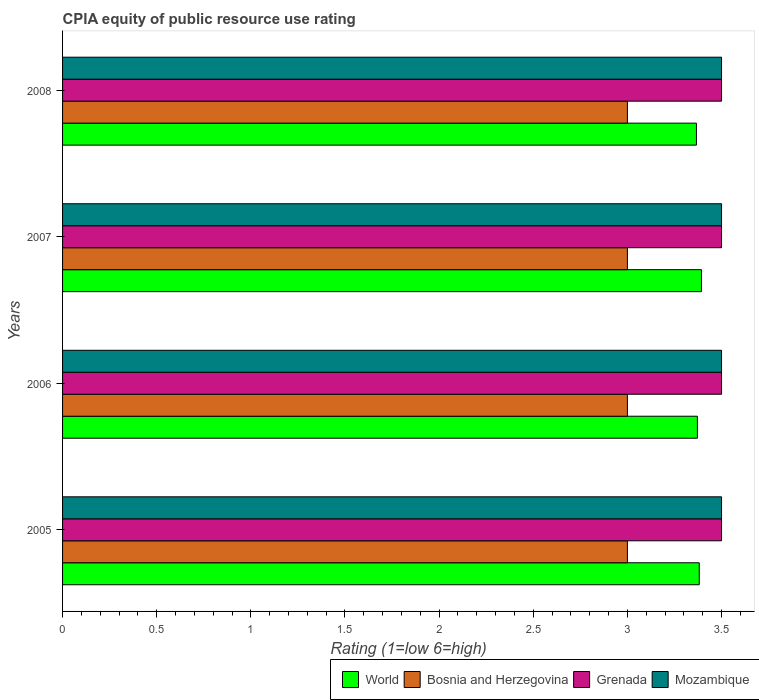How many different coloured bars are there?
Offer a terse response. 4. How many groups of bars are there?
Provide a succinct answer. 4. How many bars are there on the 4th tick from the bottom?
Keep it short and to the point. 4. In how many cases, is the number of bars for a given year not equal to the number of legend labels?
Ensure brevity in your answer.  0. What is the CPIA rating in World in 2005?
Make the answer very short. 3.38. Across all years, what is the maximum CPIA rating in Mozambique?
Your response must be concise. 3.5. In which year was the CPIA rating in Mozambique minimum?
Provide a succinct answer. 2005. What is the difference between the CPIA rating in Grenada in 2006 and the CPIA rating in Bosnia and Herzegovina in 2008?
Keep it short and to the point. 0.5. What is the ratio of the CPIA rating in Grenada in 2005 to that in 2007?
Make the answer very short. 1. Is the CPIA rating in Grenada in 2007 less than that in 2008?
Keep it short and to the point. No. What is the difference between the highest and the lowest CPIA rating in World?
Offer a very short reply. 0.03. Is the sum of the CPIA rating in Bosnia and Herzegovina in 2005 and 2008 greater than the maximum CPIA rating in Mozambique across all years?
Your response must be concise. Yes. Is it the case that in every year, the sum of the CPIA rating in Bosnia and Herzegovina and CPIA rating in World is greater than the sum of CPIA rating in Mozambique and CPIA rating in Grenada?
Give a very brief answer. No. What does the 4th bar from the top in 2008 represents?
Provide a short and direct response. World. What does the 3rd bar from the bottom in 2008 represents?
Provide a short and direct response. Grenada. Is it the case that in every year, the sum of the CPIA rating in Bosnia and Herzegovina and CPIA rating in World is greater than the CPIA rating in Mozambique?
Make the answer very short. Yes. How many bars are there?
Provide a succinct answer. 16. Are all the bars in the graph horizontal?
Keep it short and to the point. Yes. What is the difference between two consecutive major ticks on the X-axis?
Your response must be concise. 0.5. Are the values on the major ticks of X-axis written in scientific E-notation?
Give a very brief answer. No. Does the graph contain any zero values?
Provide a succinct answer. No. Does the graph contain grids?
Give a very brief answer. No. How are the legend labels stacked?
Provide a short and direct response. Horizontal. What is the title of the graph?
Provide a succinct answer. CPIA equity of public resource use rating. Does "Dominican Republic" appear as one of the legend labels in the graph?
Provide a succinct answer. No. What is the label or title of the Y-axis?
Keep it short and to the point. Years. What is the Rating (1=low 6=high) of World in 2005?
Your response must be concise. 3.38. What is the Rating (1=low 6=high) in World in 2006?
Ensure brevity in your answer.  3.37. What is the Rating (1=low 6=high) in Bosnia and Herzegovina in 2006?
Offer a terse response. 3. What is the Rating (1=low 6=high) in World in 2007?
Your answer should be very brief. 3.39. What is the Rating (1=low 6=high) of Bosnia and Herzegovina in 2007?
Offer a terse response. 3. What is the Rating (1=low 6=high) in World in 2008?
Offer a terse response. 3.37. What is the Rating (1=low 6=high) of Grenada in 2008?
Your answer should be very brief. 3.5. Across all years, what is the maximum Rating (1=low 6=high) of World?
Your response must be concise. 3.39. Across all years, what is the maximum Rating (1=low 6=high) in Bosnia and Herzegovina?
Provide a short and direct response. 3. Across all years, what is the minimum Rating (1=low 6=high) of World?
Your answer should be compact. 3.37. What is the total Rating (1=low 6=high) of World in the graph?
Give a very brief answer. 13.51. What is the total Rating (1=low 6=high) of Bosnia and Herzegovina in the graph?
Provide a succinct answer. 12. What is the total Rating (1=low 6=high) in Grenada in the graph?
Offer a very short reply. 14. What is the difference between the Rating (1=low 6=high) in World in 2005 and that in 2006?
Keep it short and to the point. 0.01. What is the difference between the Rating (1=low 6=high) in Bosnia and Herzegovina in 2005 and that in 2006?
Ensure brevity in your answer.  0. What is the difference between the Rating (1=low 6=high) in Grenada in 2005 and that in 2006?
Keep it short and to the point. 0. What is the difference between the Rating (1=low 6=high) in World in 2005 and that in 2007?
Ensure brevity in your answer.  -0.01. What is the difference between the Rating (1=low 6=high) in Bosnia and Herzegovina in 2005 and that in 2007?
Keep it short and to the point. 0. What is the difference between the Rating (1=low 6=high) of Grenada in 2005 and that in 2007?
Make the answer very short. 0. What is the difference between the Rating (1=low 6=high) in World in 2005 and that in 2008?
Offer a terse response. 0.01. What is the difference between the Rating (1=low 6=high) of Bosnia and Herzegovina in 2005 and that in 2008?
Offer a terse response. 0. What is the difference between the Rating (1=low 6=high) in Grenada in 2005 and that in 2008?
Offer a very short reply. 0. What is the difference between the Rating (1=low 6=high) of World in 2006 and that in 2007?
Ensure brevity in your answer.  -0.02. What is the difference between the Rating (1=low 6=high) in World in 2006 and that in 2008?
Make the answer very short. 0.01. What is the difference between the Rating (1=low 6=high) of Grenada in 2006 and that in 2008?
Offer a terse response. 0. What is the difference between the Rating (1=low 6=high) in Mozambique in 2006 and that in 2008?
Your answer should be very brief. 0. What is the difference between the Rating (1=low 6=high) of World in 2007 and that in 2008?
Your answer should be very brief. 0.03. What is the difference between the Rating (1=low 6=high) in Bosnia and Herzegovina in 2007 and that in 2008?
Your answer should be very brief. 0. What is the difference between the Rating (1=low 6=high) of World in 2005 and the Rating (1=low 6=high) of Bosnia and Herzegovina in 2006?
Keep it short and to the point. 0.38. What is the difference between the Rating (1=low 6=high) of World in 2005 and the Rating (1=low 6=high) of Grenada in 2006?
Make the answer very short. -0.12. What is the difference between the Rating (1=low 6=high) of World in 2005 and the Rating (1=low 6=high) of Mozambique in 2006?
Make the answer very short. -0.12. What is the difference between the Rating (1=low 6=high) of Grenada in 2005 and the Rating (1=low 6=high) of Mozambique in 2006?
Give a very brief answer. 0. What is the difference between the Rating (1=low 6=high) in World in 2005 and the Rating (1=low 6=high) in Bosnia and Herzegovina in 2007?
Keep it short and to the point. 0.38. What is the difference between the Rating (1=low 6=high) in World in 2005 and the Rating (1=low 6=high) in Grenada in 2007?
Offer a terse response. -0.12. What is the difference between the Rating (1=low 6=high) of World in 2005 and the Rating (1=low 6=high) of Mozambique in 2007?
Your response must be concise. -0.12. What is the difference between the Rating (1=low 6=high) of Bosnia and Herzegovina in 2005 and the Rating (1=low 6=high) of Grenada in 2007?
Keep it short and to the point. -0.5. What is the difference between the Rating (1=low 6=high) in World in 2005 and the Rating (1=low 6=high) in Bosnia and Herzegovina in 2008?
Give a very brief answer. 0.38. What is the difference between the Rating (1=low 6=high) in World in 2005 and the Rating (1=low 6=high) in Grenada in 2008?
Your answer should be very brief. -0.12. What is the difference between the Rating (1=low 6=high) of World in 2005 and the Rating (1=low 6=high) of Mozambique in 2008?
Your response must be concise. -0.12. What is the difference between the Rating (1=low 6=high) of Bosnia and Herzegovina in 2005 and the Rating (1=low 6=high) of Mozambique in 2008?
Make the answer very short. -0.5. What is the difference between the Rating (1=low 6=high) in World in 2006 and the Rating (1=low 6=high) in Bosnia and Herzegovina in 2007?
Ensure brevity in your answer.  0.37. What is the difference between the Rating (1=low 6=high) in World in 2006 and the Rating (1=low 6=high) in Grenada in 2007?
Your answer should be compact. -0.13. What is the difference between the Rating (1=low 6=high) in World in 2006 and the Rating (1=low 6=high) in Mozambique in 2007?
Make the answer very short. -0.13. What is the difference between the Rating (1=low 6=high) in Bosnia and Herzegovina in 2006 and the Rating (1=low 6=high) in Mozambique in 2007?
Offer a very short reply. -0.5. What is the difference between the Rating (1=low 6=high) in Grenada in 2006 and the Rating (1=low 6=high) in Mozambique in 2007?
Give a very brief answer. 0. What is the difference between the Rating (1=low 6=high) in World in 2006 and the Rating (1=low 6=high) in Bosnia and Herzegovina in 2008?
Provide a short and direct response. 0.37. What is the difference between the Rating (1=low 6=high) in World in 2006 and the Rating (1=low 6=high) in Grenada in 2008?
Provide a succinct answer. -0.13. What is the difference between the Rating (1=low 6=high) in World in 2006 and the Rating (1=low 6=high) in Mozambique in 2008?
Your answer should be compact. -0.13. What is the difference between the Rating (1=low 6=high) in Bosnia and Herzegovina in 2006 and the Rating (1=low 6=high) in Grenada in 2008?
Keep it short and to the point. -0.5. What is the difference between the Rating (1=low 6=high) of World in 2007 and the Rating (1=low 6=high) of Bosnia and Herzegovina in 2008?
Your answer should be very brief. 0.39. What is the difference between the Rating (1=low 6=high) of World in 2007 and the Rating (1=low 6=high) of Grenada in 2008?
Give a very brief answer. -0.11. What is the difference between the Rating (1=low 6=high) in World in 2007 and the Rating (1=low 6=high) in Mozambique in 2008?
Offer a terse response. -0.11. What is the difference between the Rating (1=low 6=high) of Bosnia and Herzegovina in 2007 and the Rating (1=low 6=high) of Mozambique in 2008?
Offer a very short reply. -0.5. What is the difference between the Rating (1=low 6=high) of Grenada in 2007 and the Rating (1=low 6=high) of Mozambique in 2008?
Provide a succinct answer. 0. What is the average Rating (1=low 6=high) of World per year?
Offer a very short reply. 3.38. What is the average Rating (1=low 6=high) of Bosnia and Herzegovina per year?
Keep it short and to the point. 3. In the year 2005, what is the difference between the Rating (1=low 6=high) in World and Rating (1=low 6=high) in Bosnia and Herzegovina?
Offer a very short reply. 0.38. In the year 2005, what is the difference between the Rating (1=low 6=high) of World and Rating (1=low 6=high) of Grenada?
Offer a terse response. -0.12. In the year 2005, what is the difference between the Rating (1=low 6=high) in World and Rating (1=low 6=high) in Mozambique?
Make the answer very short. -0.12. In the year 2005, what is the difference between the Rating (1=low 6=high) of Bosnia and Herzegovina and Rating (1=low 6=high) of Grenada?
Make the answer very short. -0.5. In the year 2006, what is the difference between the Rating (1=low 6=high) of World and Rating (1=low 6=high) of Bosnia and Herzegovina?
Give a very brief answer. 0.37. In the year 2006, what is the difference between the Rating (1=low 6=high) in World and Rating (1=low 6=high) in Grenada?
Offer a terse response. -0.13. In the year 2006, what is the difference between the Rating (1=low 6=high) of World and Rating (1=low 6=high) of Mozambique?
Provide a succinct answer. -0.13. In the year 2007, what is the difference between the Rating (1=low 6=high) in World and Rating (1=low 6=high) in Bosnia and Herzegovina?
Your answer should be compact. 0.39. In the year 2007, what is the difference between the Rating (1=low 6=high) of World and Rating (1=low 6=high) of Grenada?
Provide a succinct answer. -0.11. In the year 2007, what is the difference between the Rating (1=low 6=high) of World and Rating (1=low 6=high) of Mozambique?
Give a very brief answer. -0.11. In the year 2007, what is the difference between the Rating (1=low 6=high) in Bosnia and Herzegovina and Rating (1=low 6=high) in Mozambique?
Provide a succinct answer. -0.5. In the year 2007, what is the difference between the Rating (1=low 6=high) in Grenada and Rating (1=low 6=high) in Mozambique?
Ensure brevity in your answer.  0. In the year 2008, what is the difference between the Rating (1=low 6=high) of World and Rating (1=low 6=high) of Bosnia and Herzegovina?
Provide a short and direct response. 0.37. In the year 2008, what is the difference between the Rating (1=low 6=high) of World and Rating (1=low 6=high) of Grenada?
Your answer should be very brief. -0.13. In the year 2008, what is the difference between the Rating (1=low 6=high) in World and Rating (1=low 6=high) in Mozambique?
Your response must be concise. -0.13. In the year 2008, what is the difference between the Rating (1=low 6=high) in Bosnia and Herzegovina and Rating (1=low 6=high) in Grenada?
Your answer should be compact. -0.5. In the year 2008, what is the difference between the Rating (1=low 6=high) in Bosnia and Herzegovina and Rating (1=low 6=high) in Mozambique?
Your response must be concise. -0.5. In the year 2008, what is the difference between the Rating (1=low 6=high) in Grenada and Rating (1=low 6=high) in Mozambique?
Give a very brief answer. 0. What is the ratio of the Rating (1=low 6=high) in World in 2005 to that in 2006?
Offer a terse response. 1. What is the ratio of the Rating (1=low 6=high) of Bosnia and Herzegovina in 2005 to that in 2006?
Provide a succinct answer. 1. What is the ratio of the Rating (1=low 6=high) in Grenada in 2005 to that in 2006?
Your answer should be compact. 1. What is the ratio of the Rating (1=low 6=high) of World in 2005 to that in 2007?
Ensure brevity in your answer.  1. What is the ratio of the Rating (1=low 6=high) of Mozambique in 2005 to that in 2007?
Your answer should be compact. 1. What is the ratio of the Rating (1=low 6=high) in World in 2005 to that in 2008?
Keep it short and to the point. 1. What is the ratio of the Rating (1=low 6=high) in Bosnia and Herzegovina in 2005 to that in 2008?
Provide a succinct answer. 1. What is the ratio of the Rating (1=low 6=high) of Grenada in 2005 to that in 2008?
Your response must be concise. 1. What is the ratio of the Rating (1=low 6=high) in World in 2006 to that in 2008?
Make the answer very short. 1. What is the ratio of the Rating (1=low 6=high) in Grenada in 2006 to that in 2008?
Your answer should be very brief. 1. What is the ratio of the Rating (1=low 6=high) in Mozambique in 2006 to that in 2008?
Your answer should be very brief. 1. What is the ratio of the Rating (1=low 6=high) in World in 2007 to that in 2008?
Make the answer very short. 1.01. What is the ratio of the Rating (1=low 6=high) in Mozambique in 2007 to that in 2008?
Give a very brief answer. 1. What is the difference between the highest and the second highest Rating (1=low 6=high) of World?
Your response must be concise. 0.01. What is the difference between the highest and the second highest Rating (1=low 6=high) in Mozambique?
Provide a succinct answer. 0. What is the difference between the highest and the lowest Rating (1=low 6=high) in World?
Keep it short and to the point. 0.03. What is the difference between the highest and the lowest Rating (1=low 6=high) of Bosnia and Herzegovina?
Give a very brief answer. 0. What is the difference between the highest and the lowest Rating (1=low 6=high) of Grenada?
Offer a very short reply. 0. 